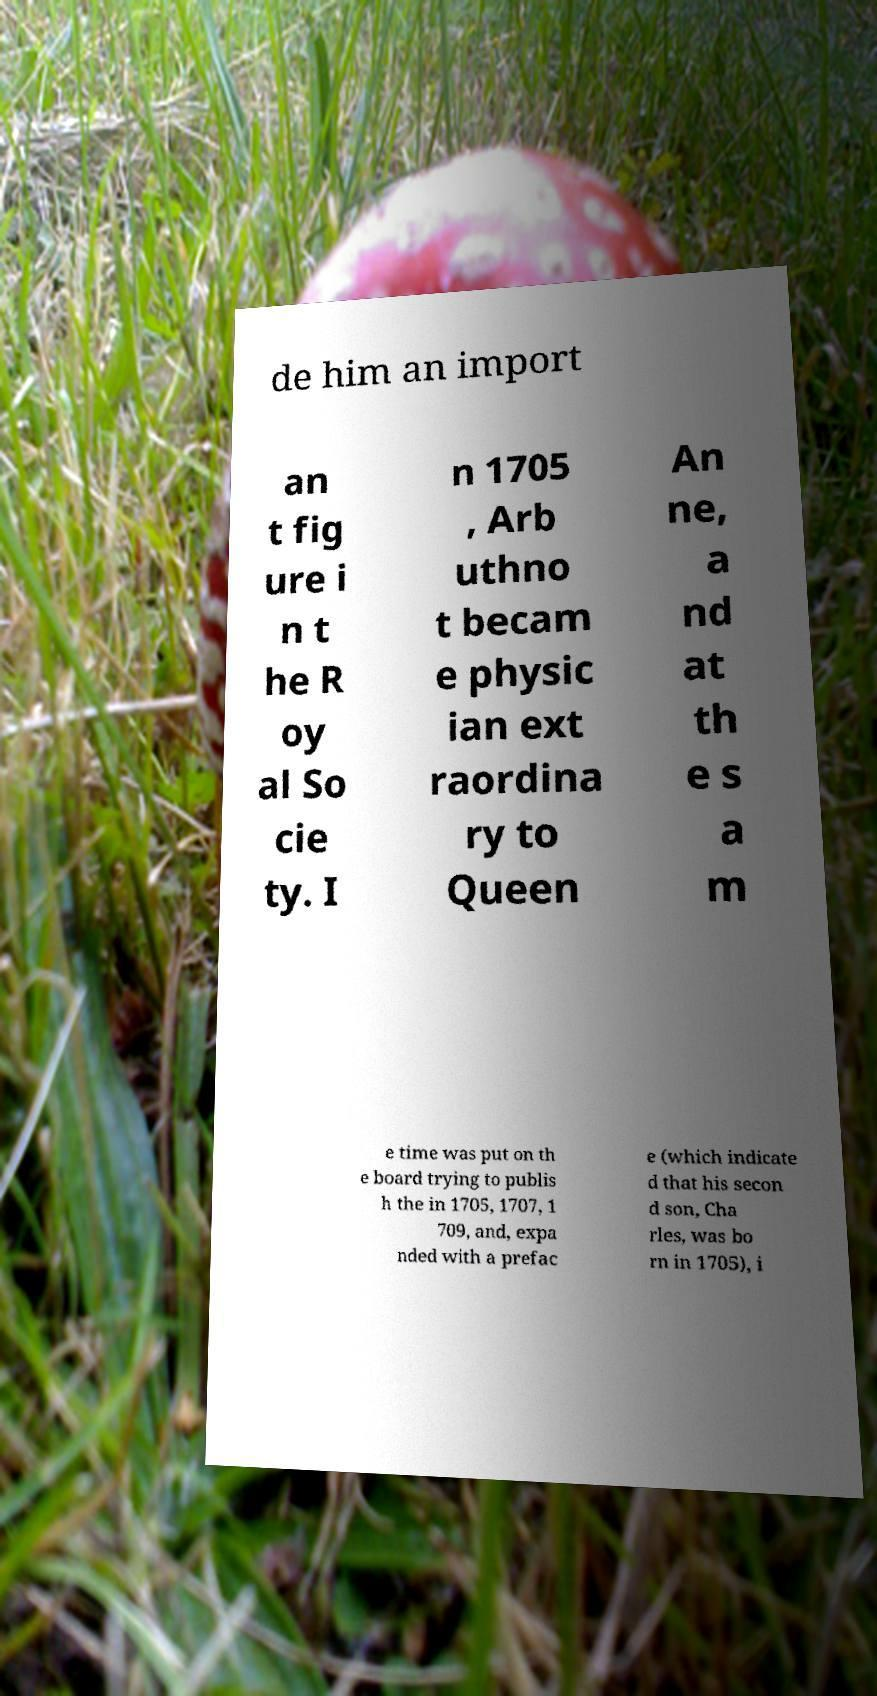What messages or text are displayed in this image? I need them in a readable, typed format. de him an import an t fig ure i n t he R oy al So cie ty. I n 1705 , Arb uthno t becam e physic ian ext raordina ry to Queen An ne, a nd at th e s a m e time was put on th e board trying to publis h the in 1705, 1707, 1 709, and, expa nded with a prefac e (which indicate d that his secon d son, Cha rles, was bo rn in 1705), i 